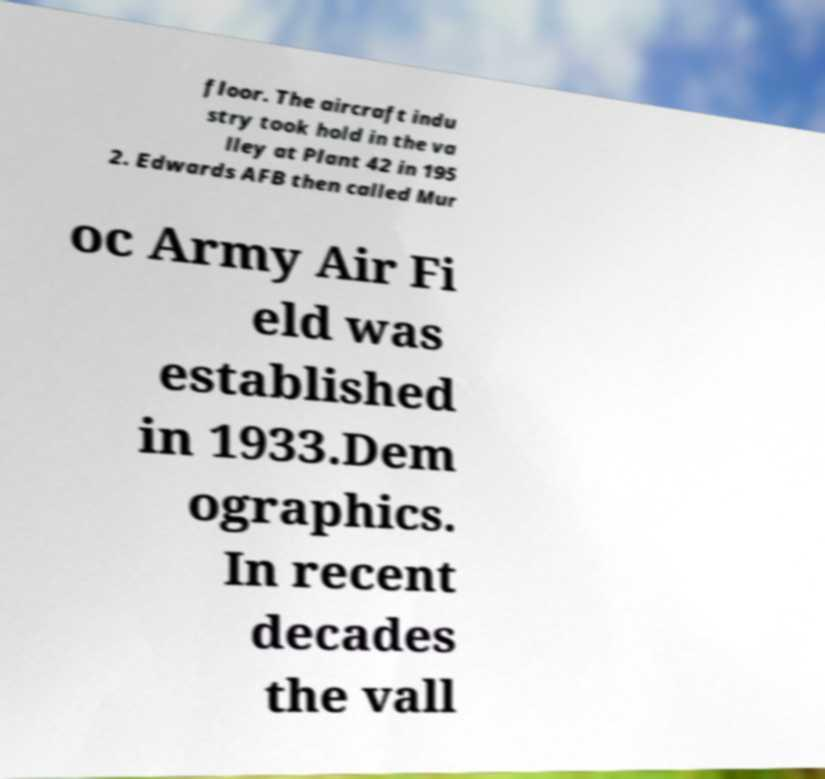There's text embedded in this image that I need extracted. Can you transcribe it verbatim? floor. The aircraft indu stry took hold in the va lley at Plant 42 in 195 2. Edwards AFB then called Mur oc Army Air Fi eld was established in 1933.Dem ographics. In recent decades the vall 